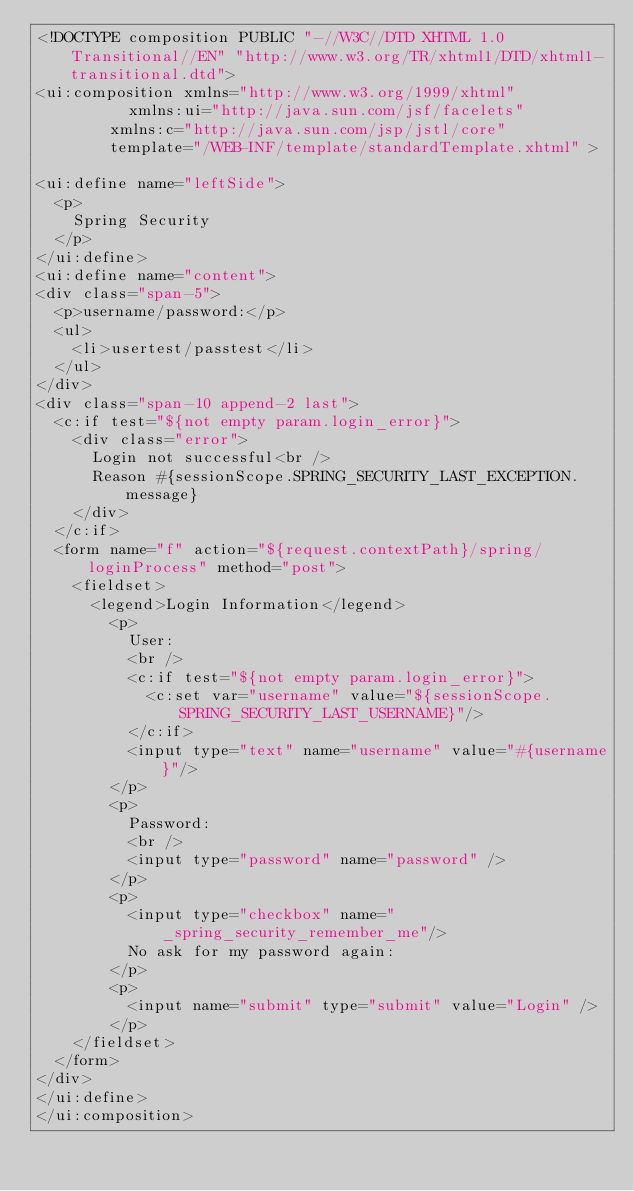<code> <loc_0><loc_0><loc_500><loc_500><_HTML_><!DOCTYPE composition PUBLIC "-//W3C//DTD XHTML 1.0 Transitional//EN" "http://www.w3.org/TR/xhtml1/DTD/xhtml1-transitional.dtd">
<ui:composition xmlns="http://www.w3.org/1999/xhtml"
	    		xmlns:ui="http://java.sun.com/jsf/facelets"
				xmlns:c="http://java.sun.com/jsp/jstl/core"
				template="/WEB-INF/template/standardTemplate.xhtml" >
				
<ui:define name="leftSide">
	<p>
		Spring Security
	</p>
</ui:define>
<ui:define name="content">
<div class="span-5">
	<p>username/password:</p>
	<ul>
		<li>usertest/passtest</li>
	</ul>
</div>
<div class="span-10 append-2 last">
	<c:if test="${not empty param.login_error}">
		<div class="error">
			Login not successful<br />
			Reason #{sessionScope.SPRING_SECURITY_LAST_EXCEPTION.message}
		</div>
	</c:if>
	<form name="f" action="${request.contextPath}/spring/loginProcess" method="post">
		<fieldset>
			<legend>Login Information</legend>
				<p>
					User:
					<br />
					<c:if test="${not empty param.login_error}">
						<c:set var="username" value="${sessionScope.SPRING_SECURITY_LAST_USERNAME}"/>
					</c:if>
					<input type="text" name="username" value="#{username}"/>
				</p>
				<p>
					Password:
					<br />
					<input type="password" name="password" />
				</p>
				<p>
					<input type="checkbox" name="_spring_security_remember_me"/> 
					No ask for my password again:
				</p>
				<p>
					<input name="submit" type="submit" value="Login" />
				</p>
		</fieldset>
	</form>
</div>
</ui:define>
</ui:composition></code> 